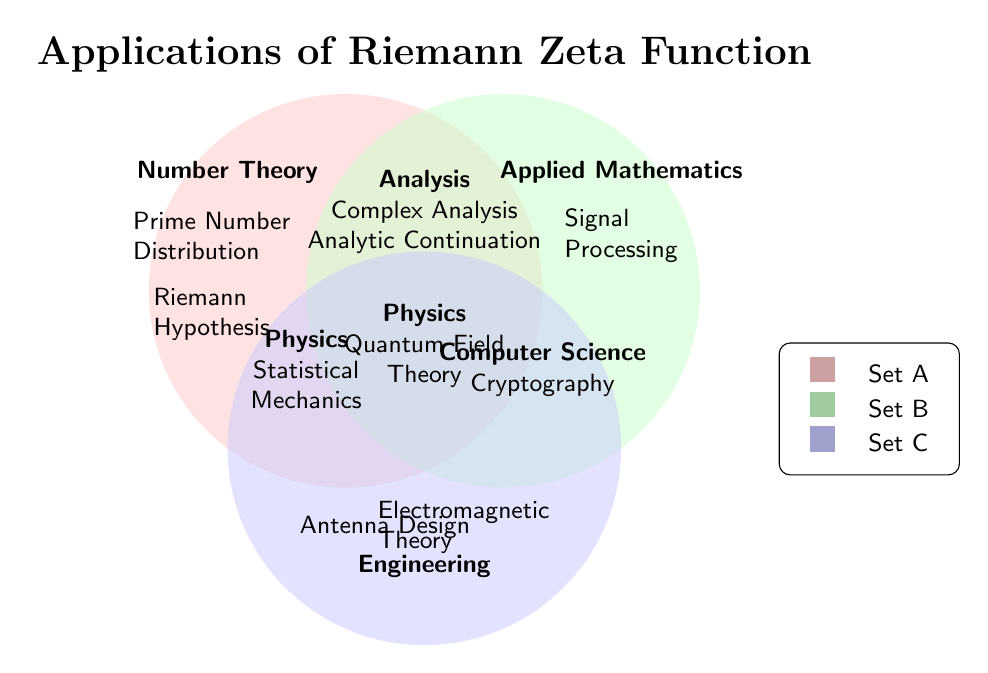What is the title of the figure? The title is displayed prominently at the top of the figure.
Answer: Applications of Riemann Zeta Function Which categories intersect with all three sets? Colors and intersections in the Venn Diagram show where all three sets overlap. The central overlapping section corresponds to this.
Answer: Physics (Quantum Field Theory) Which category is related to Prime Number Distribution? Look at the labels within the Set A section of the figure.
Answer: Number Theory Which category intersects with both Number Theory and Analysis? Check the label within the intersection between Set A and Set B.
Answer: Complex Analysis, Analytic Continuation How many applications are listed under the category of Engineering? Count the applications within the area labeled Engineering.
Answer: Two Which category has a unique intersection with Applied Mathematics? Look at the labels that are specific to Set B and not shared with Sets A or C.
Answer: Signal Processing Does Cryptography intersect with Number Theory? Check for Cryptography within the regions where Set A intersects, and find that Cryptography is not in those regions.
Answer: No Where does Statistical Mechanics appear in the diagram? Identify the section where Statistical Mechanics is labeled, within Set A and Set C's intersection.
Answer: Set A and Set C intersection (Physics) What is an application that only intersects with Set B? Look for an area that exclusively belongs to Set B.
Answer: Signal Processing Which categories are related to Complex Analysis? Check for the categories that intersect in the area labeled as Complex Analysis.
Answer: Number Theory and Analysis 